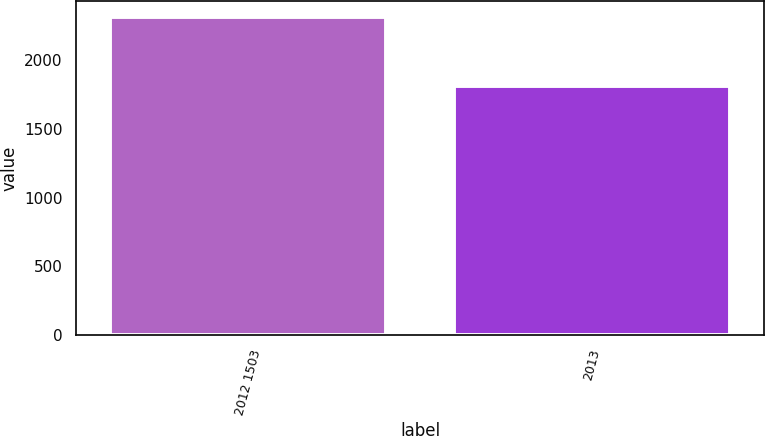Convert chart to OTSL. <chart><loc_0><loc_0><loc_500><loc_500><bar_chart><fcel>2012 1503<fcel>2013<nl><fcel>2311<fcel>1814<nl></chart> 